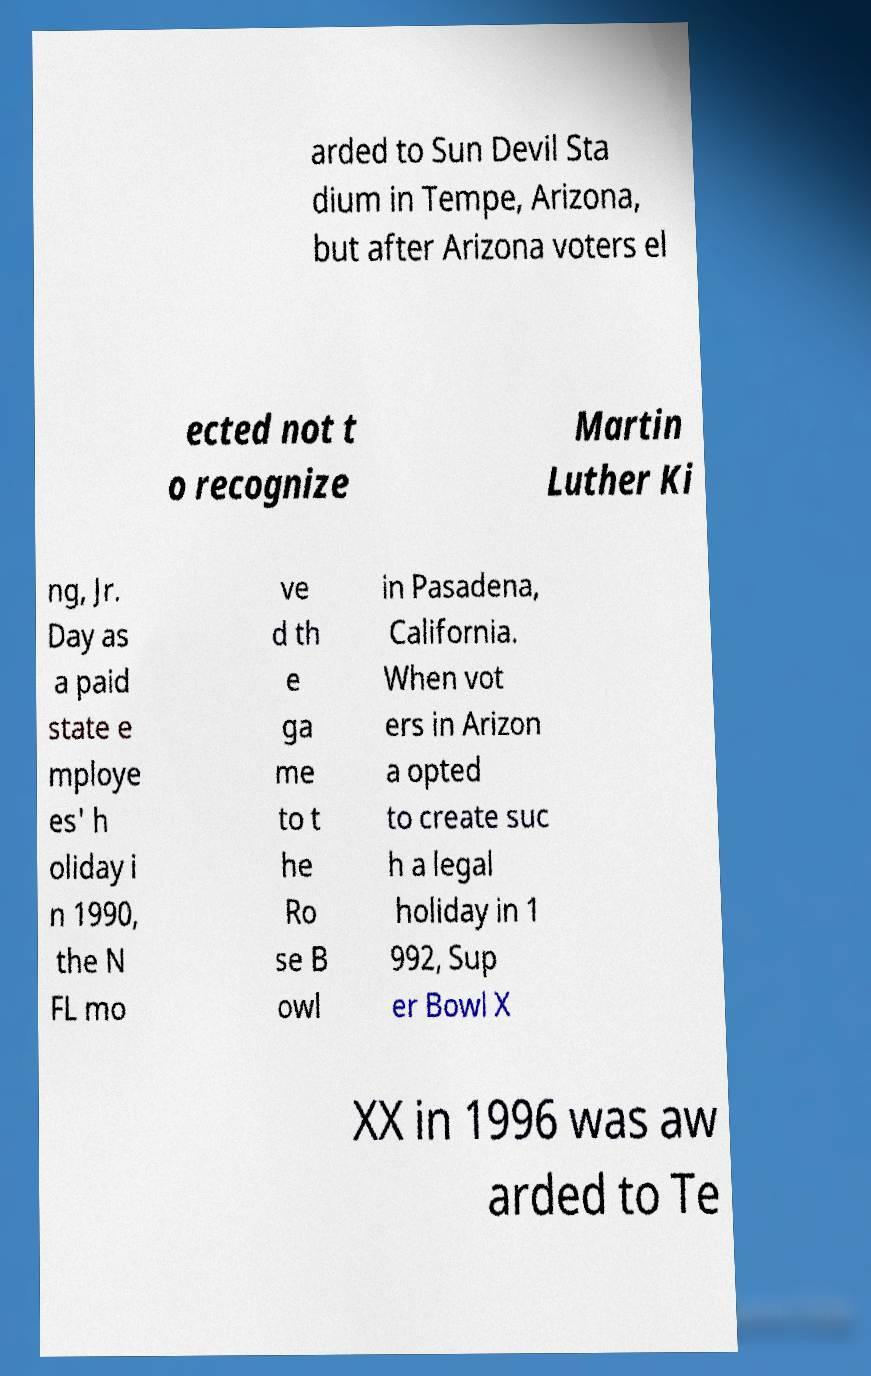Can you accurately transcribe the text from the provided image for me? arded to Sun Devil Sta dium in Tempe, Arizona, but after Arizona voters el ected not t o recognize Martin Luther Ki ng, Jr. Day as a paid state e mploye es' h oliday i n 1990, the N FL mo ve d th e ga me to t he Ro se B owl in Pasadena, California. When vot ers in Arizon a opted to create suc h a legal holiday in 1 992, Sup er Bowl X XX in 1996 was aw arded to Te 